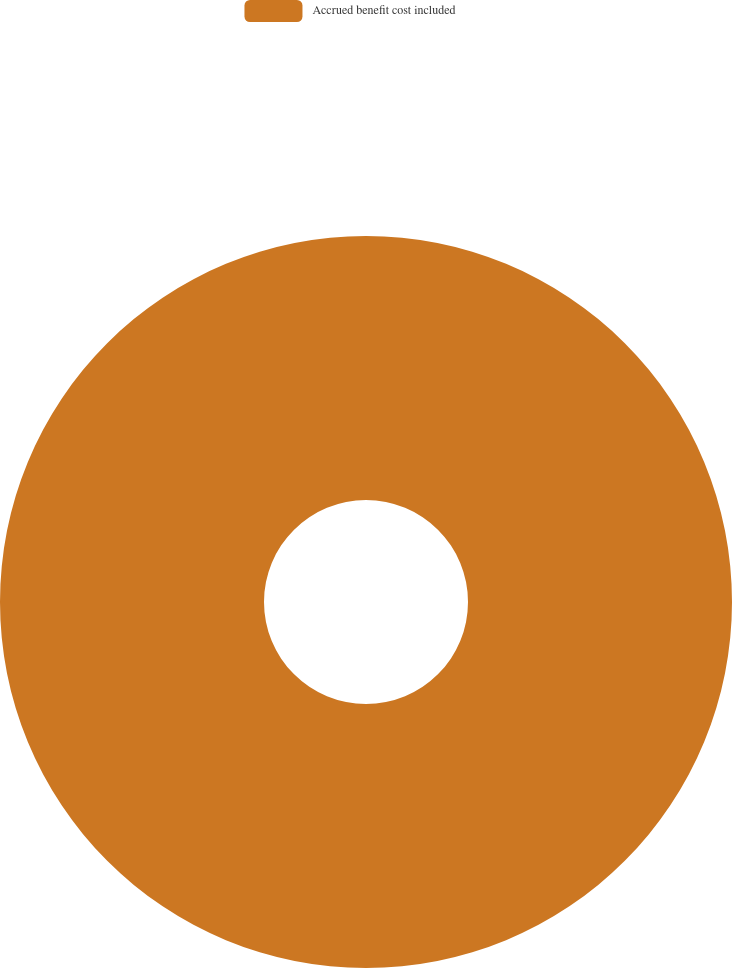Convert chart to OTSL. <chart><loc_0><loc_0><loc_500><loc_500><pie_chart><fcel>Accrued benefit cost included<nl><fcel>100.0%<nl></chart> 